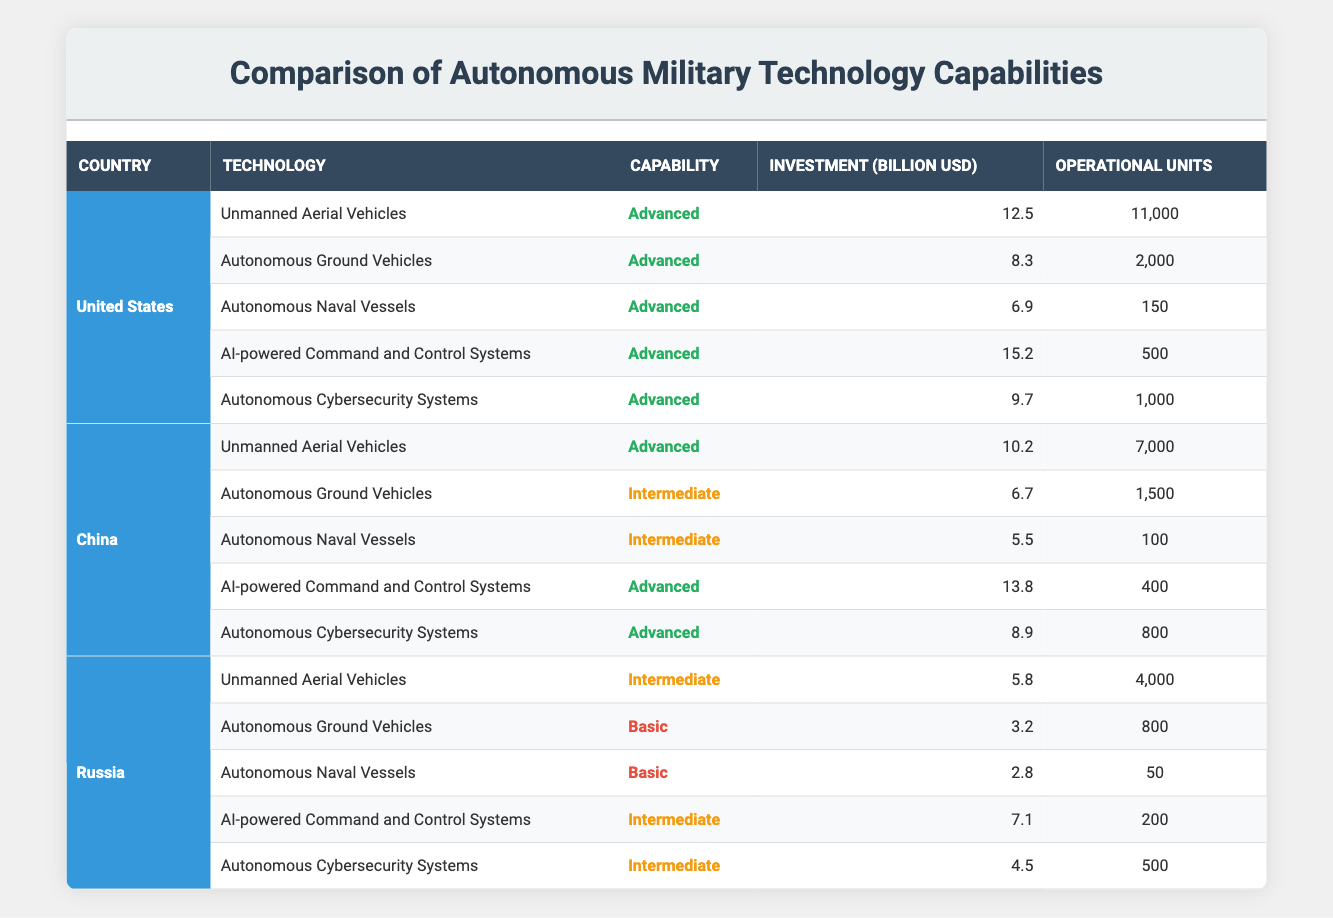What is the investment amount for the United States in Autonomous Naval Vessels? According to the table, the investment amount for the United States in Autonomous Naval Vessels is found in the row corresponding to that technology. The value listed is 6.9 billion USD.
Answer: 6.9 billion USD Which country has the highest number of operational units for Unmanned Aerial Vehicles? The operational units for Unmanned Aerial Vehicles can be found in the relevant rows for each country. The United States has 11,000 units, China has 7,000, and Russia has 4,000. Therefore, the United States has the highest number.
Answer: United States What is the total investment by Russia across all listed technologies? To find the total investment by Russia, we need to sum the investment amounts from all rows featuring Russia. The investments are 5.8, 3.2, 2.8, 7.1, and 4.5 billion USD. Summing these gives 5.8 + 3.2 + 2.8 + 7.1 + 4.5 = 23.4 billion USD.
Answer: 23.4 billion USD Is China's capability in Autonomous Ground Vehicles advanced? The table indicates that China's capability in Autonomous Ground Vehicles is listed as "Intermediate", thus the capability is not advanced.
Answer: No What is the difference in investment between AI-powered Command and Control Systems for the United States and China? The investment for AI-powered Command and Control Systems for the United States is 15.2 billion USD and for China, it is 13.8 billion USD. The difference is calculated as 15.2 - 13.8 = 1.4 billion USD.
Answer: 1.4 billion USD Which country has the lowest investment in Autonomous Cybersecurity Systems? By examining the investments listed in the Autonomous Cybersecurity Systems row for each country, we can see that Russia has an investment of 4.5 billion USD, which is lower than the other countries (United States: 9.7 billion and China: 8.9 billion).
Answer: Russia What percentage of the total operational units in Autonomous Naval Vessels does the United States represent? The operational units for the United States in Autonomous Naval Vessels is 150, while for China it's 100 and for Russia it's 50. The total operational units is 150 + 100 + 50 = 300 units. The percentage for the United States is (150/300) * 100 = 50%.
Answer: 50% Are all capabilities of the Autonomous Ground Vehicles category for the countries classified as advanced? In the table, the capabilities for Autonomous Ground Vehicles are listed as advanced for the United States, while for China it is intermediate and for Russia, it is basic. Therefore, not all capabilities are classified as advanced.
Answer: No What is the average investment across all technologies for China? First, we need to sum the investment amounts for China's technologies: 10.2 (Unmanned Aerial Vehicles) + 6.7 (Autonomous Ground Vehicles) + 5.5 (Autonomous Naval Vessels) + 13.8 (AI-powered Command and Control Systems) + 8.9 (Autonomous Cybersecurity Systems) = 45.1 billion USD. There are 5 technologies listed, so the average is 45.1/5 = 9.02 billion USD.
Answer: 9.02 billion USD 